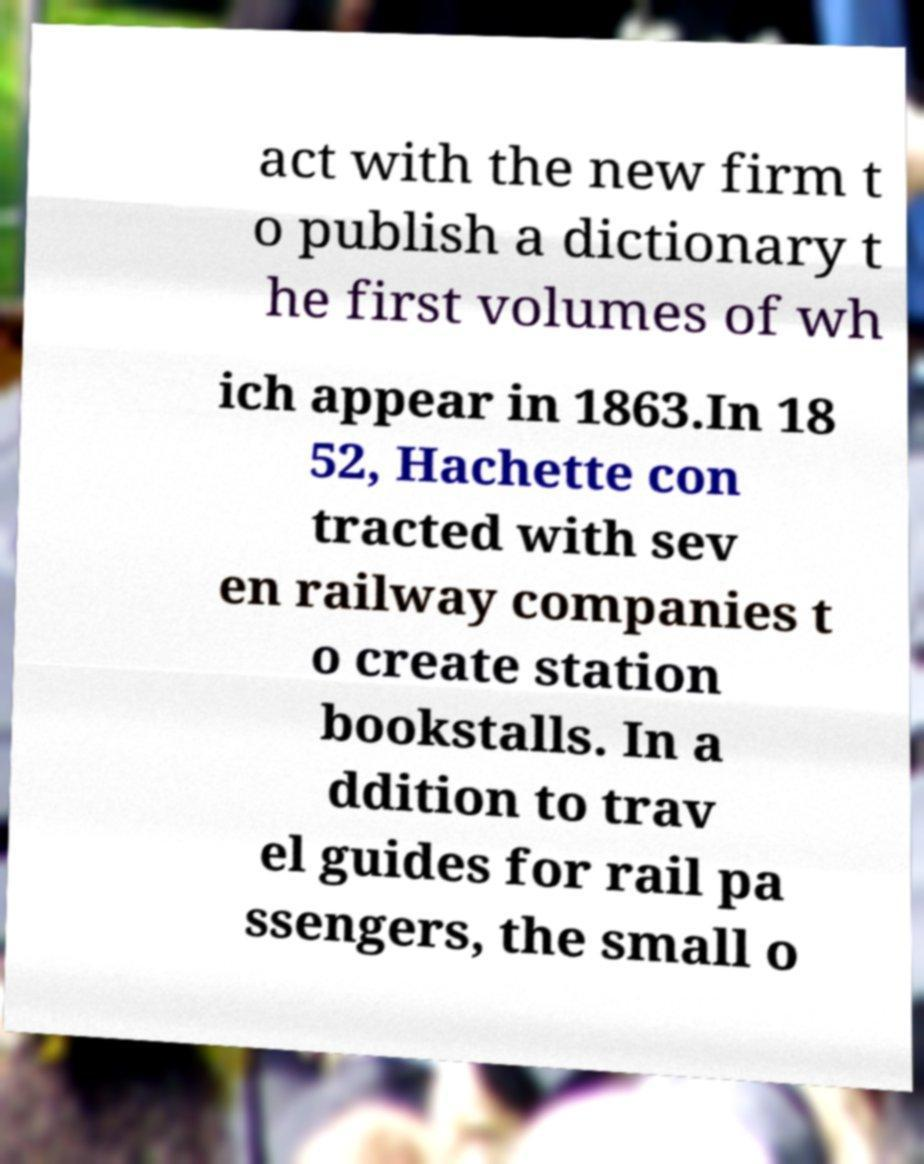What messages or text are displayed in this image? I need them in a readable, typed format. act with the new firm t o publish a dictionary t he first volumes of wh ich appear in 1863.In 18 52, Hachette con tracted with sev en railway companies t o create station bookstalls. In a ddition to trav el guides for rail pa ssengers, the small o 